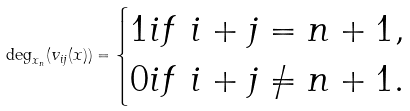Convert formula to latex. <formula><loc_0><loc_0><loc_500><loc_500>\deg _ { x _ { n } } ( v _ { i j } ( x ) ) = \begin{cases} 1 i f \ i + j = n + 1 , \\ 0 i f \ i + j \ne n + 1 . \end{cases}</formula> 